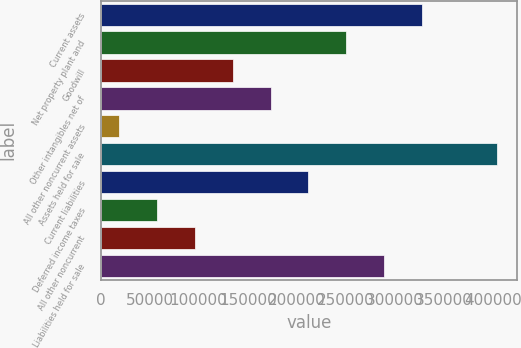Convert chart to OTSL. <chart><loc_0><loc_0><loc_500><loc_500><bar_chart><fcel>Current assets<fcel>Net property plant and<fcel>Goodwill<fcel>Other intangibles net of<fcel>All other noncurrent assets<fcel>Assets held for sale<fcel>Current liabilities<fcel>Deferred income taxes<fcel>All other noncurrent<fcel>Liabilities held for sale<nl><fcel>327404<fcel>250323<fcel>134702<fcel>173243<fcel>19081<fcel>404485<fcel>211783<fcel>57621.4<fcel>96161.8<fcel>288864<nl></chart> 